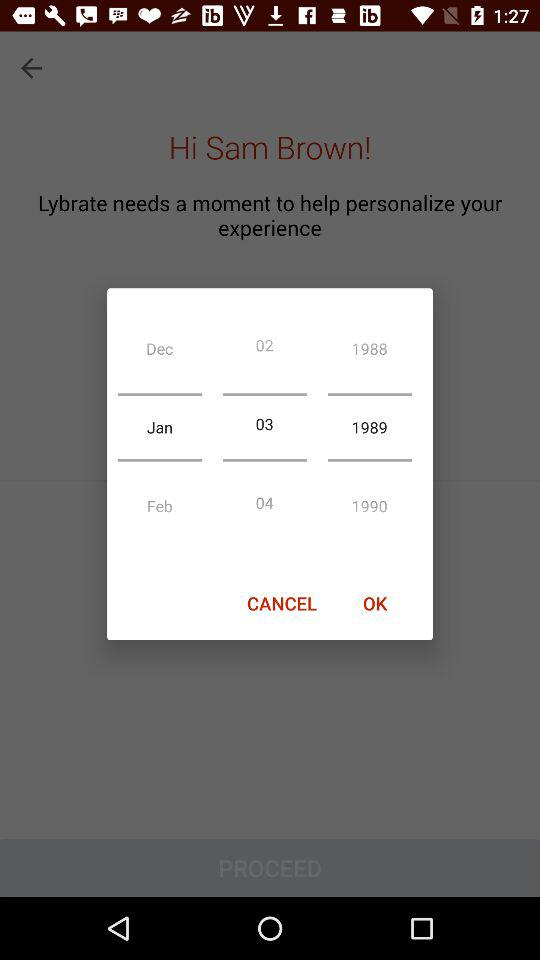Which day falls on January 3, 1989?
When the provided information is insufficient, respond with <no answer>. <no answer> 